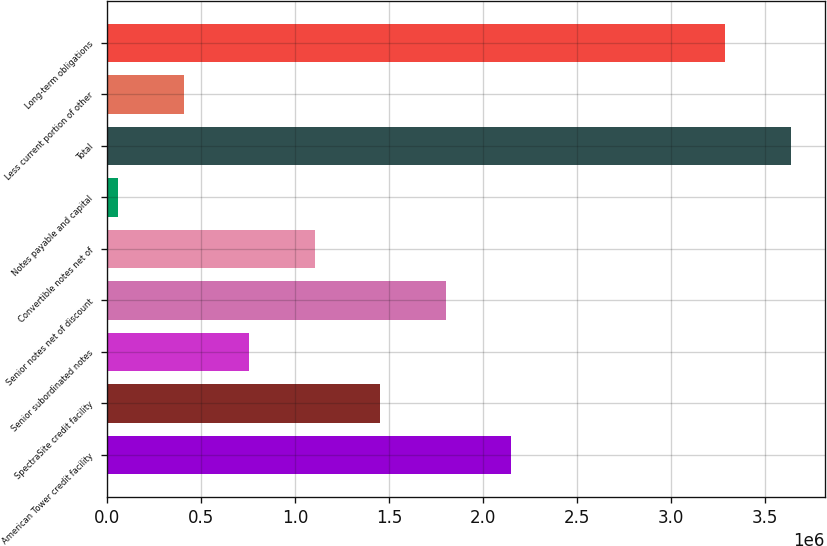<chart> <loc_0><loc_0><loc_500><loc_500><bar_chart><fcel>American Tower credit facility<fcel>SpectraSite credit facility<fcel>Senior subordinated notes<fcel>Senior notes net of discount<fcel>Convertible notes net of<fcel>Notes payable and capital<fcel>Total<fcel>Less current portion of other<fcel>Long-term obligations<nl><fcel>2.14974e+06<fcel>1.45311e+06<fcel>756474<fcel>1.80143e+06<fcel>1.10479e+06<fcel>59838<fcel>3.63743e+06<fcel>408156<fcel>3.28911e+06<nl></chart> 